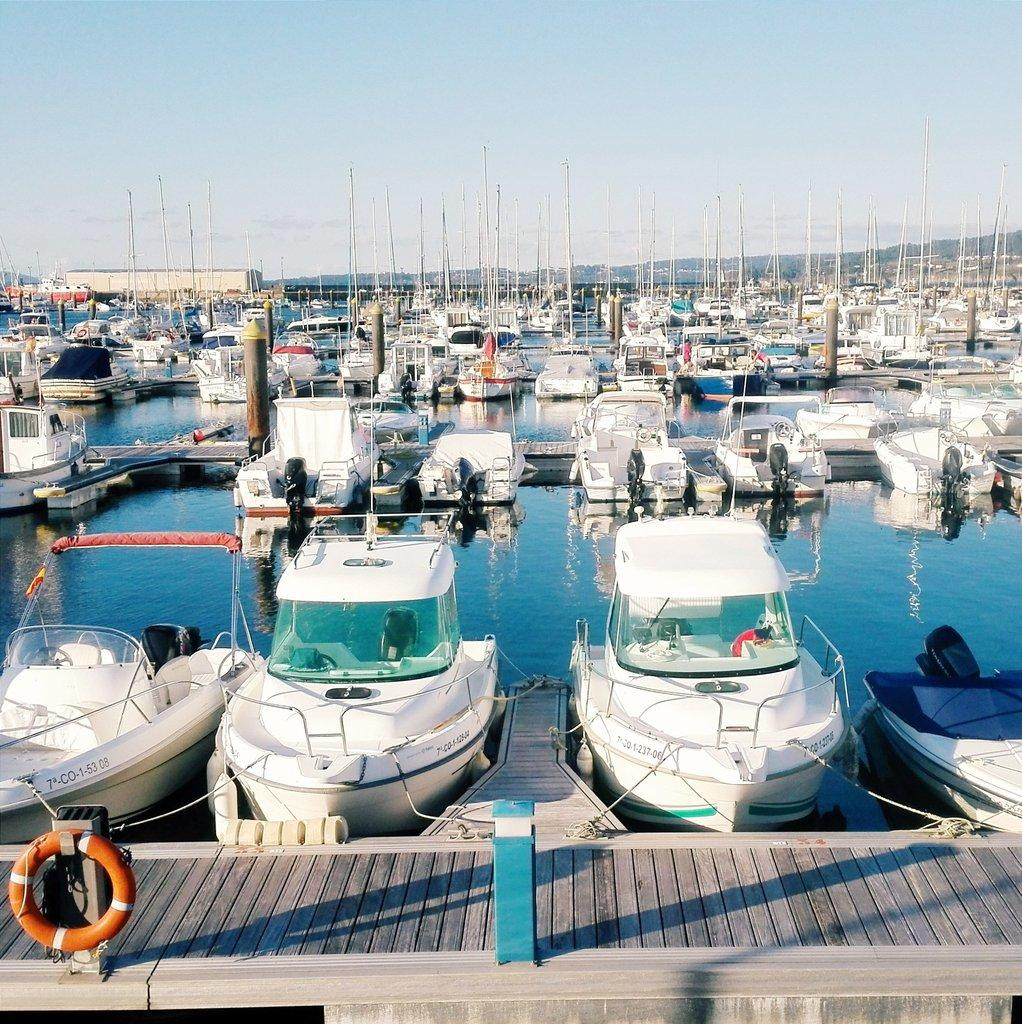What is floating on the water in the image? There are boats on the surface of the water in the image. What can be seen on the ground in the image? There is a path visible in the image. What safety feature is present in the image? A safety ring is present in the image. What is visible above the boats and path in the image? The sky is visible in the image. What type of fear is depicted in the image? There is no fear depicted in the image; it features boats on the water, a path, a safety ring, and the sky. What type of vessel is guiding the boats in the image? There is no vessel guiding the boats in the image; the boats are floating freely on the water. 